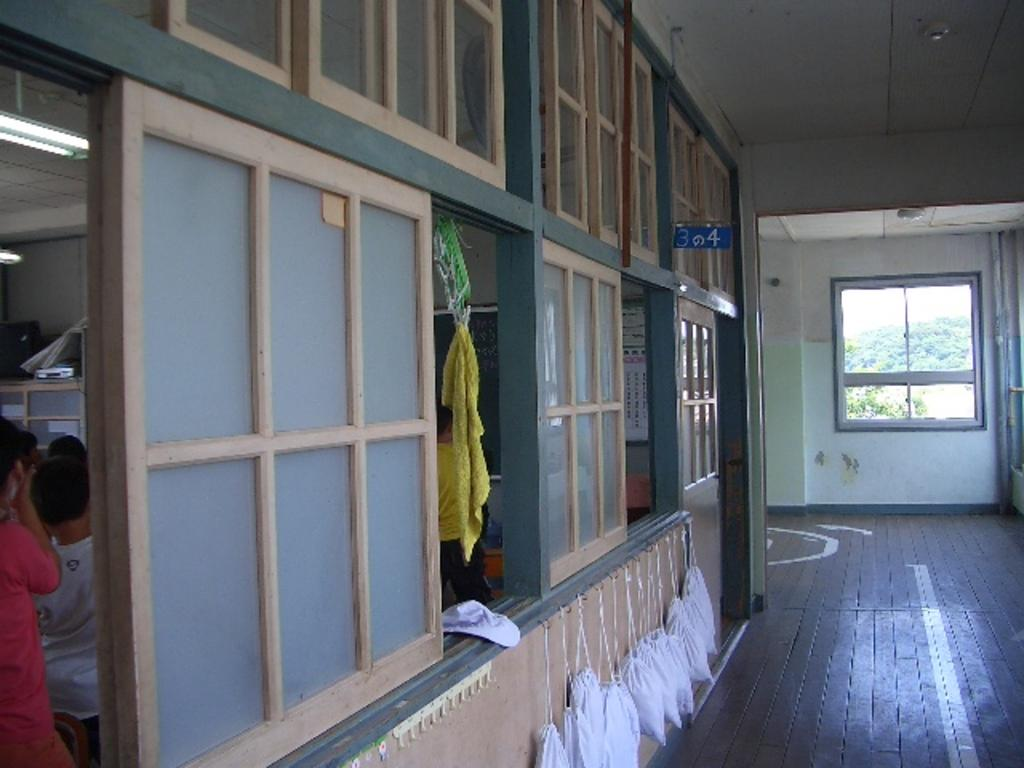What is the setting of the image? The image shows the inside of a building. Are there any people present in the image? Yes, there are people in the room. What feature of the room allows natural light to enter? There are windows in the room. What can be seen hanging on the wall? There are white bags hanging on the wall. How does the bike increase in speed in the image? There is no bike present in the image; it is set inside a building with people, windows, and white bags hanging on the wall. 